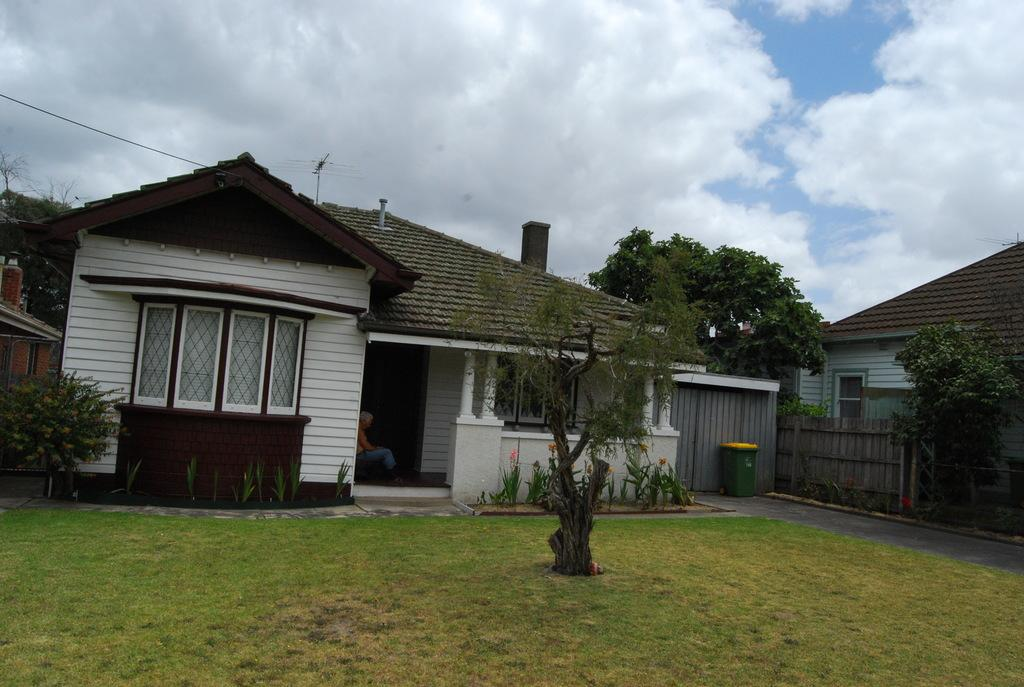How many houses are present in the image? There are two houses in the image. Can you describe the person in the image? There is a person in the image, but no specific details about their appearance or actions are provided. What type of vegetation can be seen in the image? There are trees and plants in the image. What other objects can be seen in the image besides the houses, person, trees, and plants? There are other unspecified objects in the image, but no specific details are provided. What type of punishment is being administered to the lizards in the image? There are no lizards present in the image, so no punishment is being administered. 